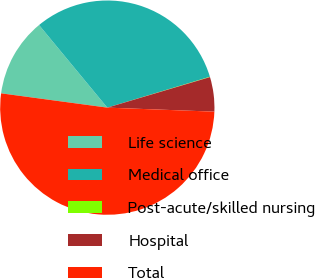Convert chart. <chart><loc_0><loc_0><loc_500><loc_500><pie_chart><fcel>Life science<fcel>Medical office<fcel>Post-acute/skilled nursing<fcel>Hospital<fcel>Total<nl><fcel>11.88%<fcel>31.34%<fcel>0.05%<fcel>5.2%<fcel>51.53%<nl></chart> 